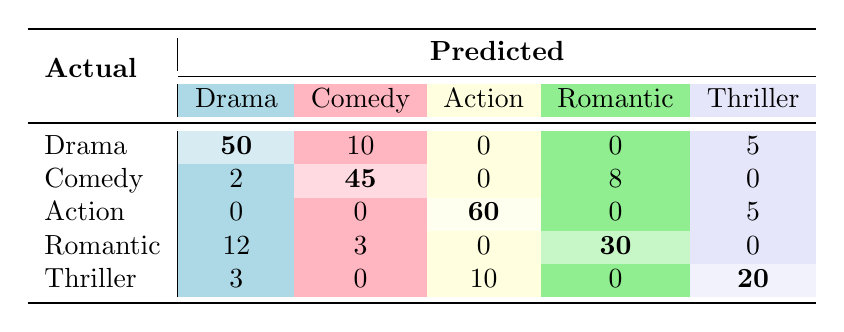What is the predicted count of Drama movies with the actual category of Drama? The table shows that there were 50 instances where the actual category was Drama, and it was correctly predicted as Drama.
Answer: 50 How many Comedy movies were incorrectly classified as Drama? The table indicates that 2 instances where the actual category was Comedy were incorrectly predicted as Drama.
Answer: 2 What is the total number of Romantic movies, based on the predictions? To find the total number of Romantic movies predicted, we add the values in the Romantic row: 12 (incorrectly predicted as Drama) + 3 (incorrectly predicted as Comedy) + 30 (correctly predicted as Romantic) = 45.
Answer: 45 How many movies were incorrectly classified as Thriller? We see that the total number of predictions classified as Thriller but were actually other genres is 0 (from Comedy) + 10 (from Action) + 0 (from Romantic) + 3 (from Drama) = 13 incorrectly classified.
Answer: 13 Is the majority of Action movies accurately predicted? Yes, looking at the Action row, 60 were accurately predicted as Action out of 80 total (60+15+5). This satisfies the majority criteria as it is more than half.
Answer: Yes Which genre had the highest number of correct predictions? By looking at the diagonal of the table, Drama has 50, Comedy has 45, Action has 60, Romantic has 30, and Thriller has 20. Action has the highest correct predictions at 60.
Answer: Action What is the difference between the correctly predicted Drama and the correctly predicted Comedy movies? The correct predictions for Drama are 50 and for Comedy are 45. The difference is 50 - 45 = 5.
Answer: 5 How many total predictions were made for Action movies? The Action predictions include 60 (correctly predicted as Action), 15 (predicted as Adventure), and 5 (predicted as Thriller). Summing these gives 60 + 15 + 5 = 80 predictions for Action movies.
Answer: 80 Was Comedy predicted more accurately than Thriller? Yes, Comedy had 45 correct predictions compared to 20 for Thriller, thus Comedy is predicted more accurately.
Answer: Yes 